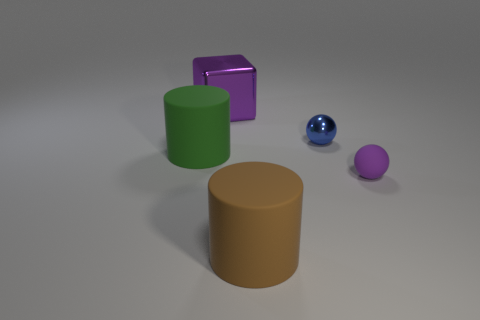There is another matte object that is the same shape as the big green thing; what is its color?
Your response must be concise. Brown. The large matte object that is in front of the rubber cylinder behind the purple matte object is what color?
Your answer should be compact. Brown. What size is the brown rubber thing that is the same shape as the green rubber thing?
Your response must be concise. Large. What number of blue spheres are the same material as the brown object?
Keep it short and to the point. 0. How many large brown objects are on the left side of the big rubber cylinder to the left of the brown rubber cylinder?
Provide a short and direct response. 0. There is a purple rubber object; are there any brown matte cylinders behind it?
Offer a terse response. No. There is a small object on the right side of the tiny shiny ball; does it have the same shape as the big brown object?
Your answer should be compact. No. There is a big block that is the same color as the matte ball; what is its material?
Offer a terse response. Metal. What number of other large blocks have the same color as the shiny block?
Provide a succinct answer. 0. What shape is the large object that is left of the metallic object behind the blue thing?
Your answer should be very brief. Cylinder. 